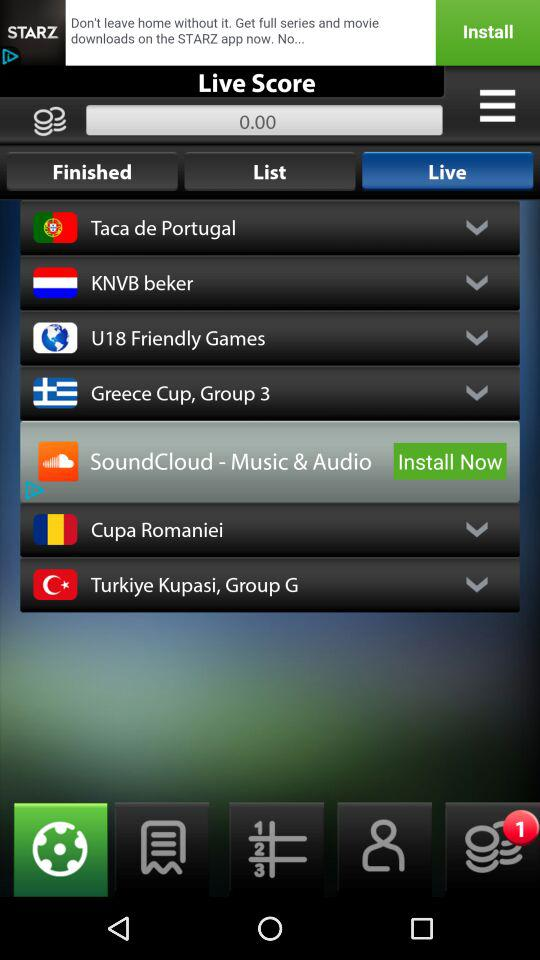Which tab is selected? The selected tab is "Live". 